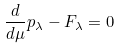Convert formula to latex. <formula><loc_0><loc_0><loc_500><loc_500>\frac { d } { d \mu } p _ { \lambda } - F _ { \lambda } = 0</formula> 